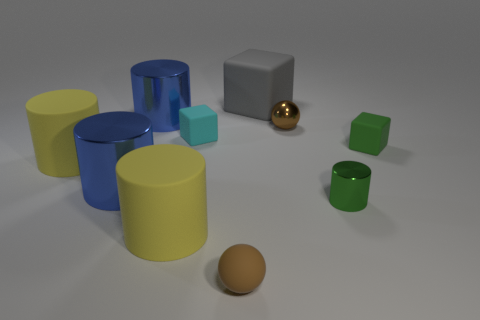What number of tiny green things are the same material as the tiny cyan object?
Ensure brevity in your answer.  1. Is the number of small purple things less than the number of tiny cyan matte cubes?
Offer a very short reply. Yes. There is another brown thing that is the same shape as the brown shiny object; what size is it?
Keep it short and to the point. Small. Is the material of the ball in front of the green rubber block the same as the cyan cube?
Your answer should be very brief. Yes. Does the green matte thing have the same shape as the cyan object?
Your answer should be very brief. Yes. How many objects are either big rubber cylinders that are in front of the tiny green metal cylinder or big metallic cylinders?
Keep it short and to the point. 3. There is a green thing that is made of the same material as the gray cube; what size is it?
Make the answer very short. Small. What number of small rubber spheres are the same color as the tiny shiny sphere?
Provide a succinct answer. 1. How many tiny objects are either purple cubes or blocks?
Keep it short and to the point. 2. What size is the matte object that is the same color as the tiny metal cylinder?
Keep it short and to the point. Small. 